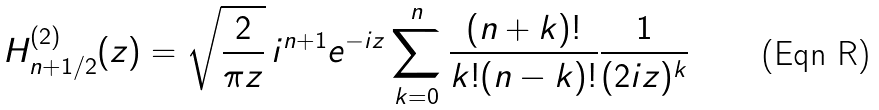<formula> <loc_0><loc_0><loc_500><loc_500>H ^ { ( 2 ) } _ { n + 1 / 2 } ( z ) = \sqrt { \frac { 2 } { \pi z } } \, i ^ { n + 1 } e ^ { - i z } \sum _ { k = 0 } ^ { n } \frac { ( n + k ) ! } { k ! ( n - k ) ! } \frac { 1 } { ( 2 i z ) ^ { k } }</formula> 